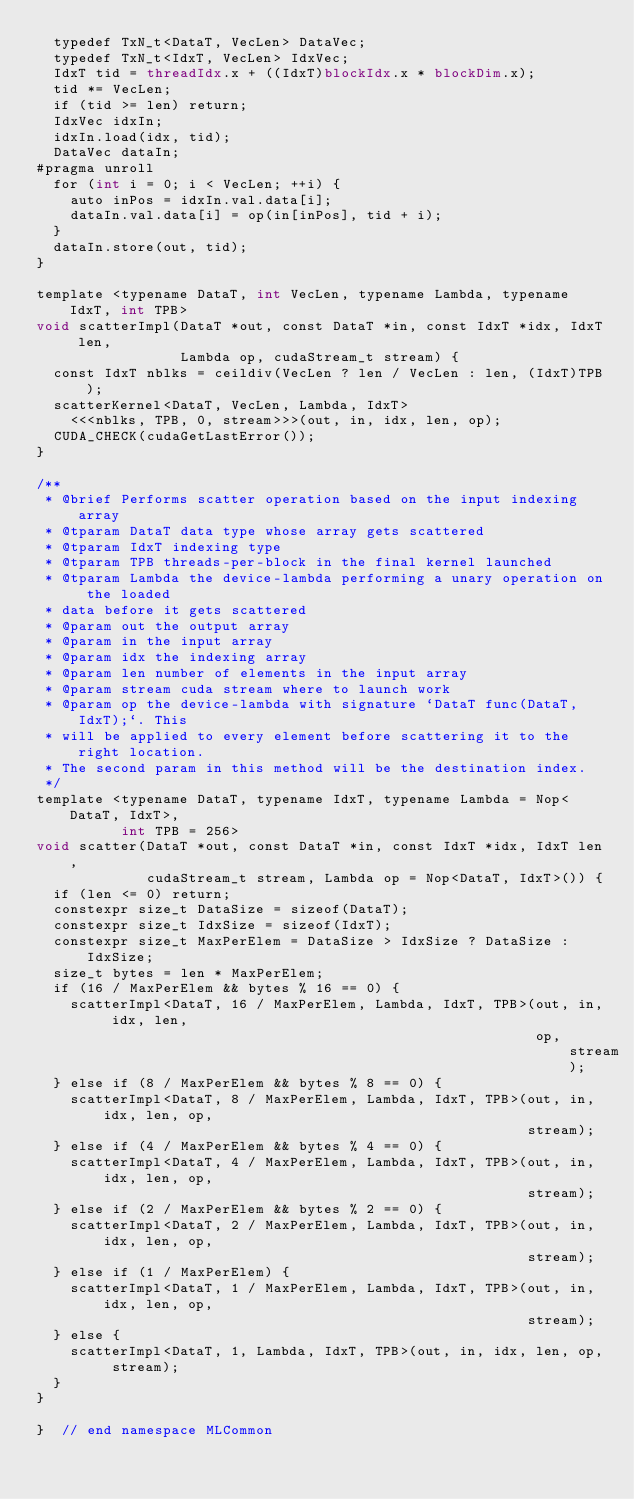<code> <loc_0><loc_0><loc_500><loc_500><_Cuda_>  typedef TxN_t<DataT, VecLen> DataVec;
  typedef TxN_t<IdxT, VecLen> IdxVec;
  IdxT tid = threadIdx.x + ((IdxT)blockIdx.x * blockDim.x);
  tid *= VecLen;
  if (tid >= len) return;
  IdxVec idxIn;
  idxIn.load(idx, tid);
  DataVec dataIn;
#pragma unroll
  for (int i = 0; i < VecLen; ++i) {
    auto inPos = idxIn.val.data[i];
    dataIn.val.data[i] = op(in[inPos], tid + i);
  }
  dataIn.store(out, tid);
}

template <typename DataT, int VecLen, typename Lambda, typename IdxT, int TPB>
void scatterImpl(DataT *out, const DataT *in, const IdxT *idx, IdxT len,
                 Lambda op, cudaStream_t stream) {
  const IdxT nblks = ceildiv(VecLen ? len / VecLen : len, (IdxT)TPB);
  scatterKernel<DataT, VecLen, Lambda, IdxT>
    <<<nblks, TPB, 0, stream>>>(out, in, idx, len, op);
  CUDA_CHECK(cudaGetLastError());
}

/**
 * @brief Performs scatter operation based on the input indexing array
 * @tparam DataT data type whose array gets scattered
 * @tparam IdxT indexing type
 * @tparam TPB threads-per-block in the final kernel launched
 * @tparam Lambda the device-lambda performing a unary operation on the loaded
 * data before it gets scattered
 * @param out the output array
 * @param in the input array
 * @param idx the indexing array
 * @param len number of elements in the input array
 * @param stream cuda stream where to launch work
 * @param op the device-lambda with signature `DataT func(DataT, IdxT);`. This
 * will be applied to every element before scattering it to the right location.
 * The second param in this method will be the destination index.
 */
template <typename DataT, typename IdxT, typename Lambda = Nop<DataT, IdxT>,
          int TPB = 256>
void scatter(DataT *out, const DataT *in, const IdxT *idx, IdxT len,
             cudaStream_t stream, Lambda op = Nop<DataT, IdxT>()) {
  if (len <= 0) return;
  constexpr size_t DataSize = sizeof(DataT);
  constexpr size_t IdxSize = sizeof(IdxT);
  constexpr size_t MaxPerElem = DataSize > IdxSize ? DataSize : IdxSize;
  size_t bytes = len * MaxPerElem;
  if (16 / MaxPerElem && bytes % 16 == 0) {
    scatterImpl<DataT, 16 / MaxPerElem, Lambda, IdxT, TPB>(out, in, idx, len,
                                                           op, stream);
  } else if (8 / MaxPerElem && bytes % 8 == 0) {
    scatterImpl<DataT, 8 / MaxPerElem, Lambda, IdxT, TPB>(out, in, idx, len, op,
                                                          stream);
  } else if (4 / MaxPerElem && bytes % 4 == 0) {
    scatterImpl<DataT, 4 / MaxPerElem, Lambda, IdxT, TPB>(out, in, idx, len, op,
                                                          stream);
  } else if (2 / MaxPerElem && bytes % 2 == 0) {
    scatterImpl<DataT, 2 / MaxPerElem, Lambda, IdxT, TPB>(out, in, idx, len, op,
                                                          stream);
  } else if (1 / MaxPerElem) {
    scatterImpl<DataT, 1 / MaxPerElem, Lambda, IdxT, TPB>(out, in, idx, len, op,
                                                          stream);
  } else {
    scatterImpl<DataT, 1, Lambda, IdxT, TPB>(out, in, idx, len, op, stream);
  }
}

}  // end namespace MLCommon
</code> 